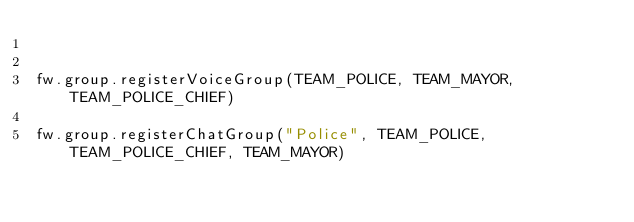<code> <loc_0><loc_0><loc_500><loc_500><_Lua_>

fw.group.registerVoiceGroup(TEAM_POLICE, TEAM_MAYOR, TEAM_POLICE_CHIEF)

fw.group.registerChatGroup("Police", TEAM_POLICE, TEAM_POLICE_CHIEF, TEAM_MAYOR)</code> 